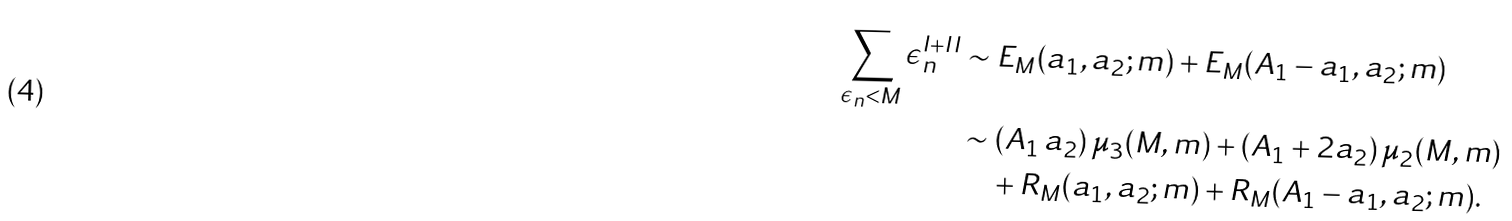Convert formula to latex. <formula><loc_0><loc_0><loc_500><loc_500>\sum _ { \epsilon _ { n } < M } \epsilon _ { n } ^ { I + I I } & \sim E _ { M } ( a _ { 1 } , a _ { 2 } ; m ) + E _ { M } ( A _ { 1 } - a _ { 1 } , a _ { 2 } ; m ) \\ & \sim ( A _ { 1 } \, a _ { 2 } ) \, \mu _ { 3 } ( M , m ) + ( A _ { 1 } + 2 a _ { 2 } ) \, \mu _ { 2 } ( M , m ) \\ & \quad + R _ { M } ( a _ { 1 } , a _ { 2 } ; m ) + R _ { M } ( A _ { 1 } - a _ { 1 } , a _ { 2 } ; m ) .</formula> 